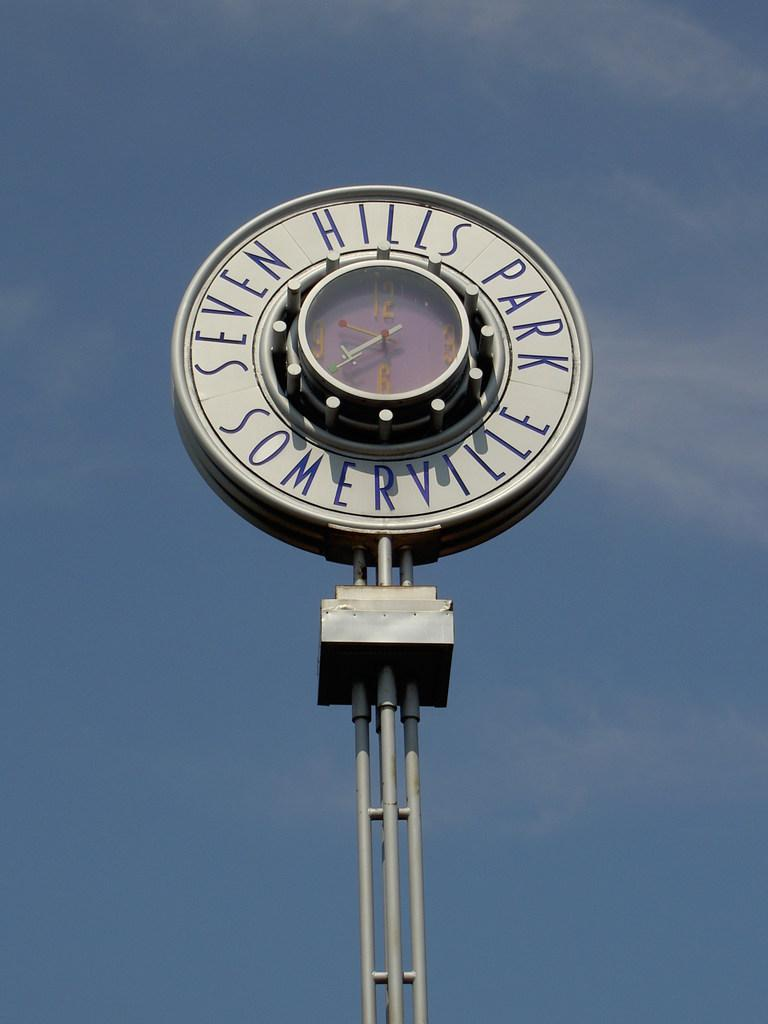<image>
Summarize the visual content of the image. A clock that reads Seven Hills Park Somerville stands against the sky. 